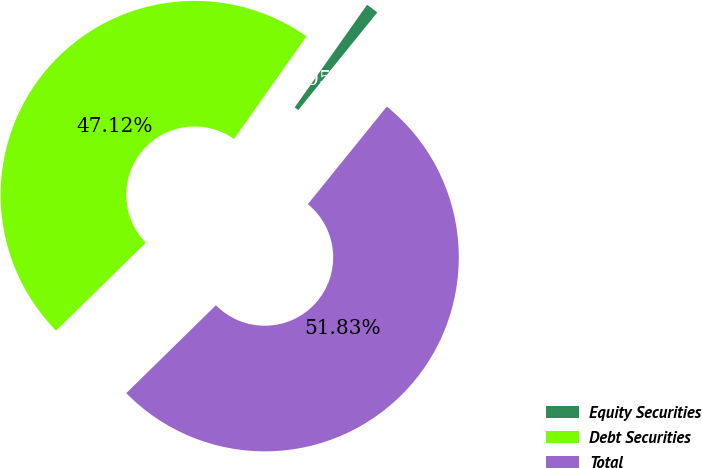Convert chart to OTSL. <chart><loc_0><loc_0><loc_500><loc_500><pie_chart><fcel>Equity Securities<fcel>Debt Securities<fcel>Total<nl><fcel>1.05%<fcel>47.12%<fcel>51.83%<nl></chart> 